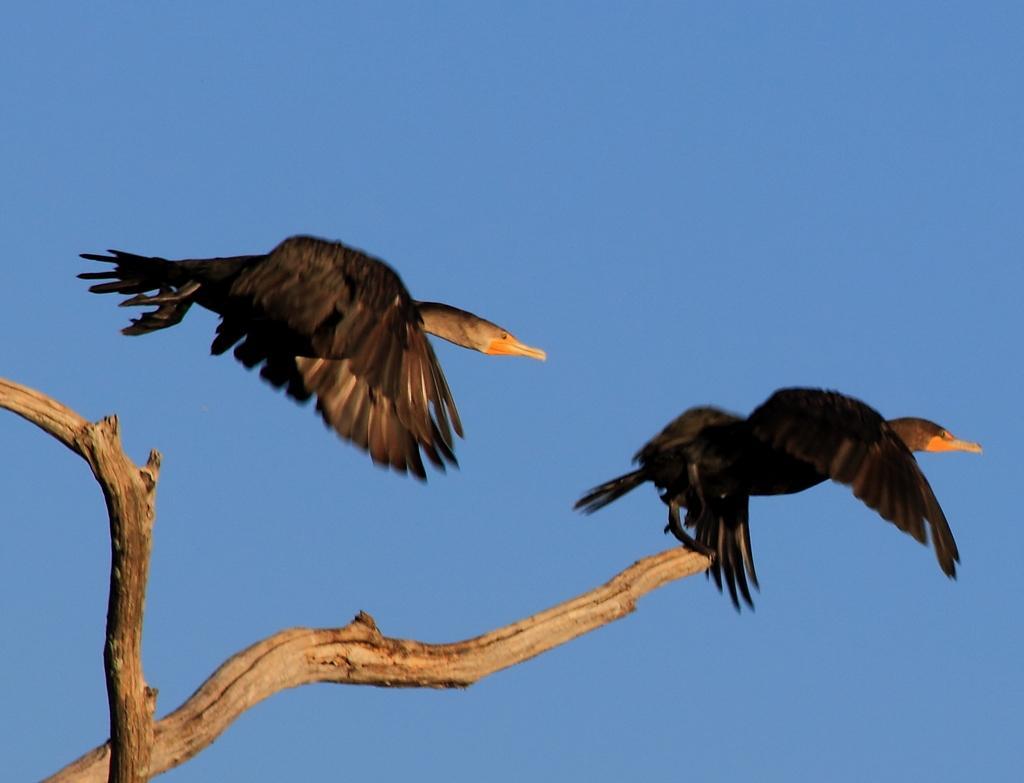Could you give a brief overview of what you see in this image? In this picture we can see a bird flying in the air. We can see another bird on a wooden branch. Sky is blue in color. 